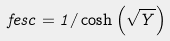Convert formula to latex. <formula><loc_0><loc_0><loc_500><loc_500>\ f e s c = 1 / \cosh \left ( \sqrt { Y } \right )</formula> 